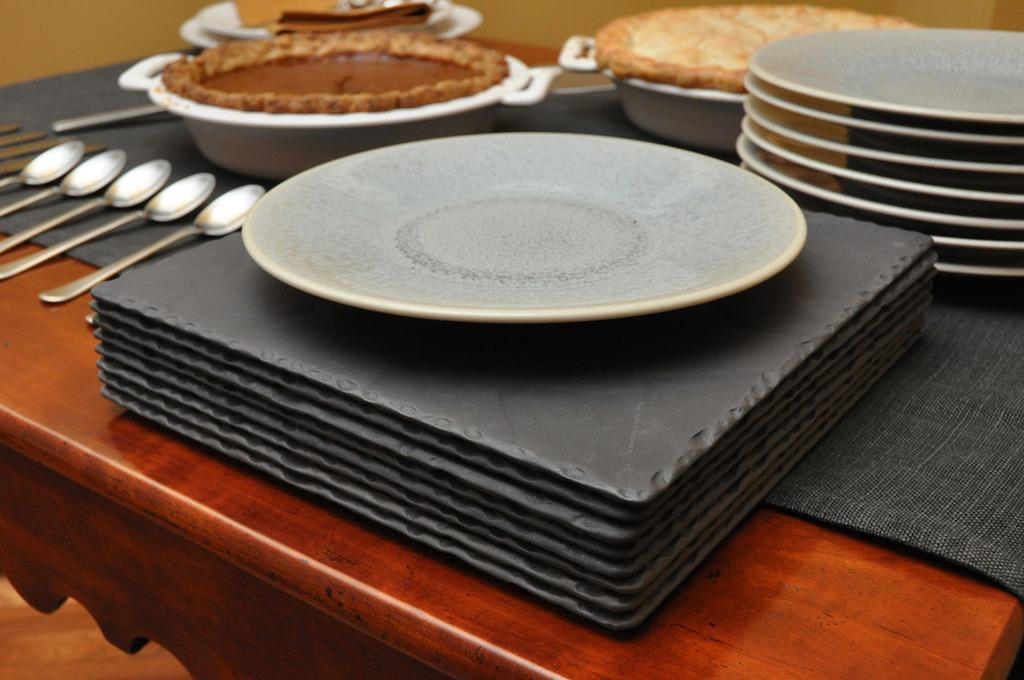What piece of furniture is present in the image? There is a table in the image. What items are placed on the table? The table has plates and spoons on it. What can be found on the table besides utensils? There are eatables on the table. What page number is the bird reading in the image? There is no bird or page present in the image. 